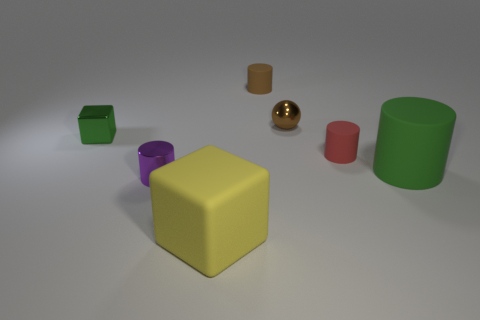Can you tell me what the different colors of the objects are in this scene? Certainly! In this scene, we have objects in various colors: there's a yellow cube right at the center, a green cube in the back, a purple cylinder to its right, a red cylinder towards the front, a gold sphere, and a green cylinder farthest to the right. 